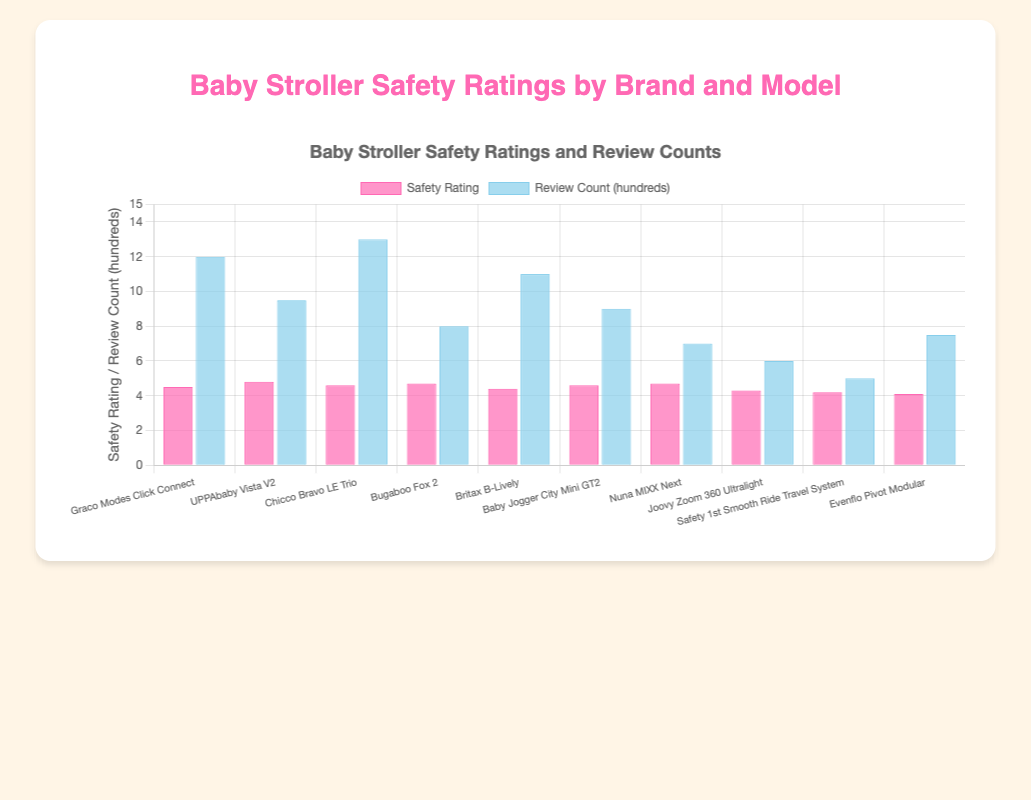What's the safety rating of the "UPPAbaby Vista V2"? Identify the bar corresponding to "UPPAbaby Vista V2" and read off the safety rating from the value on the y-axis.
Answer: 4.8 Which brand has the highest review count? Look for the tallest bar in the "Review Count" category across all the brands. "Chicco Bravo LE Trio" has the highest review count.
Answer: Chicco What's the difference in safety ratings between the "Graco Modes Click Connect" and the "Safety 1st Smooth Ride Travel System"? Identify the safety ratings of "Graco Modes Click Connect" (4.5) and "Safety 1st Smooth Ride Travel System" (4.2), then subtract the latter from the former: 4.5 - 4.2 = 0.3.
Answer: 0.3 Which brand has a higher safety rating: "Nuna MIXX Next" or "Joovy Zoom 360 Ultralight"? Compare the heights of the bars representing safety ratings for "Nuna MIXX Next" (4.7) and "Joovy Zoom 360 Ultralight" (4.3).
Answer: Nuna MIXX Next How many brands have a safety rating greater than 4.5? Count the number of bars in the "Safety Rating" category that exceed the 4.5 mark. There are 5 brands: "UPPAbaby Vista V2", "Chicco Bravo LE Trio", "Bugaboo Fox 2", "Nuna MIXX Next", "Graco Modes Click Connect".
Answer: 5 Which model has a higher review count: "Bugaboo Fox 2" or "Britax B-Lively"? Compare the bars in the "Review Count" category for "Bugaboo Fox 2" (800) and "Britax B-Lively" (1100).
Answer: Britax B-Lively What's the average safety rating of all brands combined? Sum all safety ratings and divide by the number of brands: (4.5 + 4.8 + 4.6 + 4.7 + 4.4 + 4.6 + 4.7 + 4.3 + 4.2 + 4.1) / 10 = 4.49.
Answer: 4.49 Between "Baby Jogger City Mini GT2" and "Evenflo Pivot Modular", which has a higher safety rating and by how much? Compare the safety ratings: "Baby Jogger City Mini GT2" (4.6) and "Evenflo Pivot Modular" (4.1). The difference is 4.6 - 4.1 = 0.5.
Answer: Baby Jogger City Mini GT2, by 0.5 Which stroller model has the lowest review count? Identify the bar with the smallest height in the "Review Count" category, which is "Safety 1st Smooth Ride Travel System" with a review count of 500.
Answer: Safety 1st Smooth Ride Travel System 